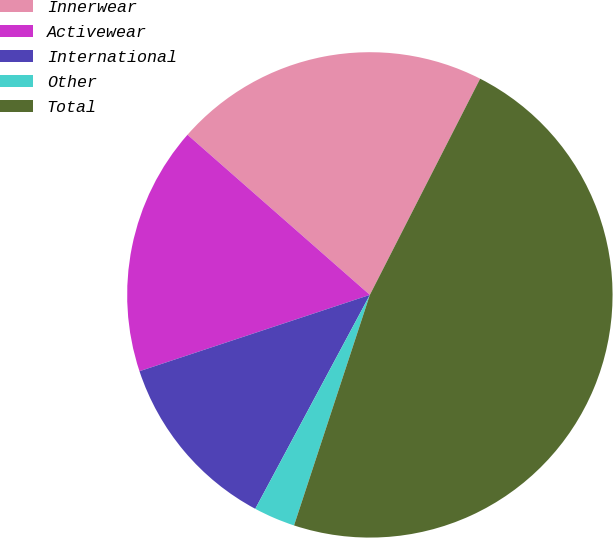<chart> <loc_0><loc_0><loc_500><loc_500><pie_chart><fcel>Innerwear<fcel>Activewear<fcel>International<fcel>Other<fcel>Total<nl><fcel>21.04%<fcel>16.56%<fcel>12.08%<fcel>2.77%<fcel>47.55%<nl></chart> 